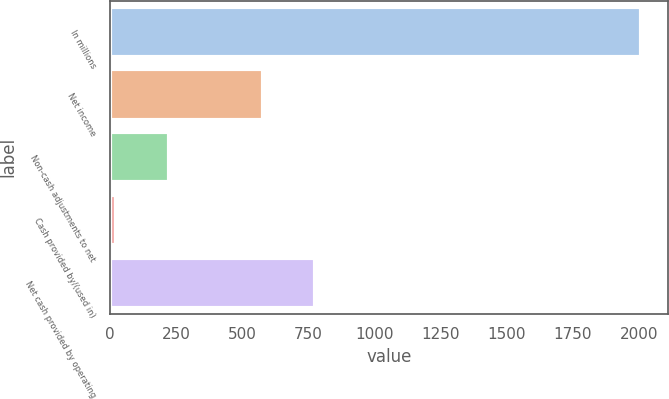<chart> <loc_0><loc_0><loc_500><loc_500><bar_chart><fcel>In millions<fcel>Net income<fcel>Non-cash adjustments to net<fcel>Cash provided by/(used in)<fcel>Net cash provided by operating<nl><fcel>2008<fcel>576.1<fcel>221.68<fcel>23.2<fcel>774.58<nl></chart> 